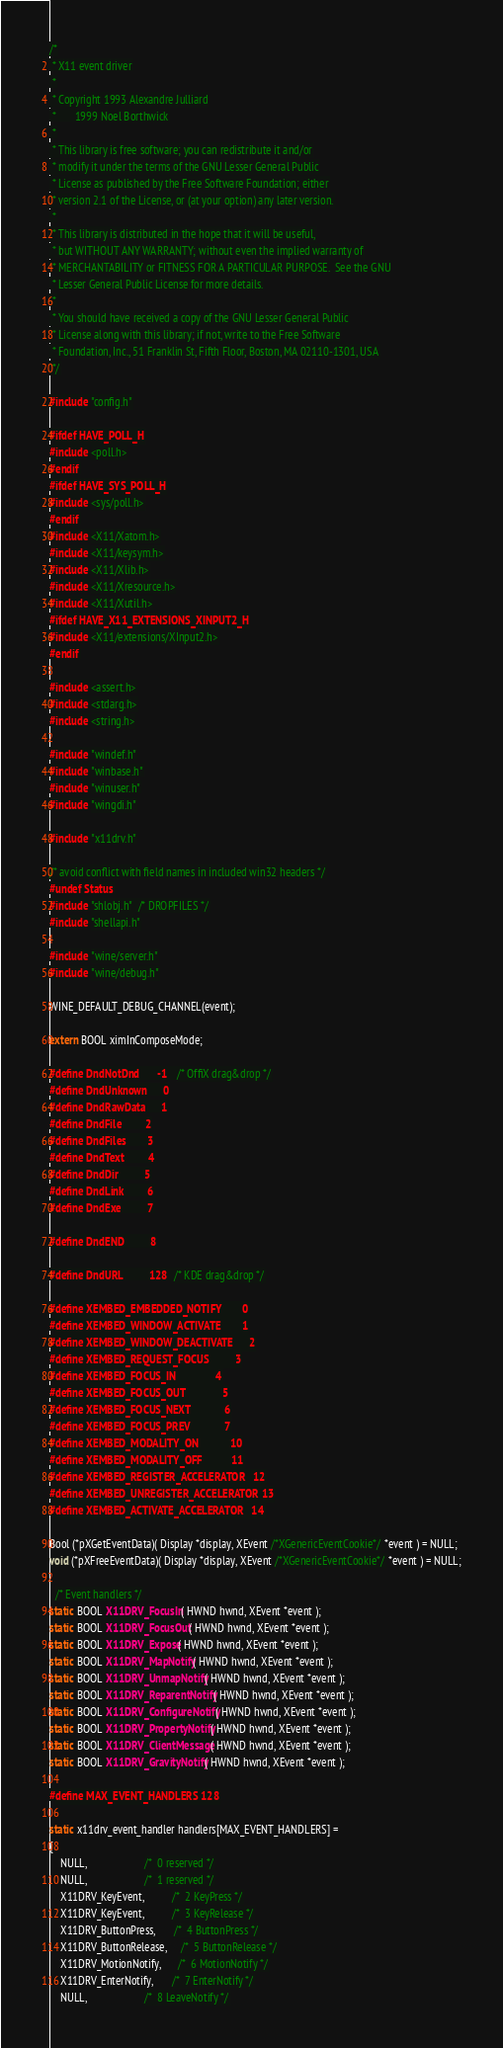<code> <loc_0><loc_0><loc_500><loc_500><_C_>/*
 * X11 event driver
 *
 * Copyright 1993 Alexandre Julliard
 *	     1999 Noel Borthwick
 *
 * This library is free software; you can redistribute it and/or
 * modify it under the terms of the GNU Lesser General Public
 * License as published by the Free Software Foundation; either
 * version 2.1 of the License, or (at your option) any later version.
 *
 * This library is distributed in the hope that it will be useful,
 * but WITHOUT ANY WARRANTY; without even the implied warranty of
 * MERCHANTABILITY or FITNESS FOR A PARTICULAR PURPOSE.  See the GNU
 * Lesser General Public License for more details.
 *
 * You should have received a copy of the GNU Lesser General Public
 * License along with this library; if not, write to the Free Software
 * Foundation, Inc., 51 Franklin St, Fifth Floor, Boston, MA 02110-1301, USA
 */

#include "config.h"

#ifdef HAVE_POLL_H
#include <poll.h>
#endif
#ifdef HAVE_SYS_POLL_H
#include <sys/poll.h>
#endif
#include <X11/Xatom.h>
#include <X11/keysym.h>
#include <X11/Xlib.h>
#include <X11/Xresource.h>
#include <X11/Xutil.h>
#ifdef HAVE_X11_EXTENSIONS_XINPUT2_H
#include <X11/extensions/XInput2.h>
#endif

#include <assert.h>
#include <stdarg.h>
#include <string.h>

#include "windef.h"
#include "winbase.h"
#include "winuser.h"
#include "wingdi.h"

#include "x11drv.h"

/* avoid conflict with field names in included win32 headers */
#undef Status
#include "shlobj.h"  /* DROPFILES */
#include "shellapi.h"

#include "wine/server.h"
#include "wine/debug.h"

WINE_DEFAULT_DEBUG_CHANNEL(event);

extern BOOL ximInComposeMode;

#define DndNotDnd       -1    /* OffiX drag&drop */
#define DndUnknown      0
#define DndRawData      1
#define DndFile         2
#define DndFiles        3
#define DndText         4
#define DndDir          5
#define DndLink         6
#define DndExe          7

#define DndEND          8

#define DndURL          128   /* KDE drag&drop */

#define XEMBED_EMBEDDED_NOTIFY        0
#define XEMBED_WINDOW_ACTIVATE        1
#define XEMBED_WINDOW_DEACTIVATE      2
#define XEMBED_REQUEST_FOCUS          3
#define XEMBED_FOCUS_IN               4
#define XEMBED_FOCUS_OUT              5
#define XEMBED_FOCUS_NEXT             6
#define XEMBED_FOCUS_PREV             7
#define XEMBED_MODALITY_ON            10
#define XEMBED_MODALITY_OFF           11
#define XEMBED_REGISTER_ACCELERATOR   12
#define XEMBED_UNREGISTER_ACCELERATOR 13
#define XEMBED_ACTIVATE_ACCELERATOR   14

Bool (*pXGetEventData)( Display *display, XEvent /*XGenericEventCookie*/ *event ) = NULL;
void (*pXFreeEventData)( Display *display, XEvent /*XGenericEventCookie*/ *event ) = NULL;

  /* Event handlers */
static BOOL X11DRV_FocusIn( HWND hwnd, XEvent *event );
static BOOL X11DRV_FocusOut( HWND hwnd, XEvent *event );
static BOOL X11DRV_Expose( HWND hwnd, XEvent *event );
static BOOL X11DRV_MapNotify( HWND hwnd, XEvent *event );
static BOOL X11DRV_UnmapNotify( HWND hwnd, XEvent *event );
static BOOL X11DRV_ReparentNotify( HWND hwnd, XEvent *event );
static BOOL X11DRV_ConfigureNotify( HWND hwnd, XEvent *event );
static BOOL X11DRV_PropertyNotify( HWND hwnd, XEvent *event );
static BOOL X11DRV_ClientMessage( HWND hwnd, XEvent *event );
static BOOL X11DRV_GravityNotify( HWND hwnd, XEvent *event );

#define MAX_EVENT_HANDLERS 128

static x11drv_event_handler handlers[MAX_EVENT_HANDLERS] =
{
    NULL,                     /*  0 reserved */
    NULL,                     /*  1 reserved */
    X11DRV_KeyEvent,          /*  2 KeyPress */
    X11DRV_KeyEvent,          /*  3 KeyRelease */
    X11DRV_ButtonPress,       /*  4 ButtonPress */
    X11DRV_ButtonRelease,     /*  5 ButtonRelease */
    X11DRV_MotionNotify,      /*  6 MotionNotify */
    X11DRV_EnterNotify,       /*  7 EnterNotify */
    NULL,                     /*  8 LeaveNotify */</code> 